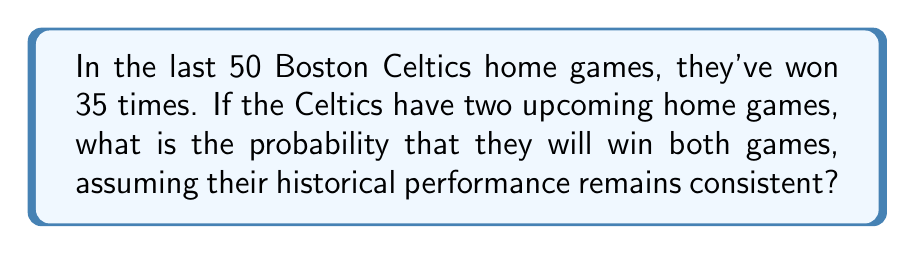Give your solution to this math problem. Let's approach this step-by-step:

1) First, we need to calculate the probability of the Celtics winning a single home game based on the given data.

   Probability of winning a home game = $\frac{\text{Number of wins}}{\text{Total games}}$
   
   $P(\text{win}) = \frac{35}{50} = 0.7$

2) Now, we need to find the probability of winning both games. Since we assume the games are independent events (the outcome of one doesn't affect the other), we can use the multiplication rule of probability.

3) For independent events, the probability of both events occurring is the product of their individual probabilities.

   $P(\text{win both}) = P(\text{win first}) \times P(\text{win second})$

4) Since the probability of winning each game is the same (0.7), we have:

   $P(\text{win both}) = 0.7 \times 0.7 = 0.7^2$

5) Calculate the final probability:

   $P(\text{win both}) = 0.7^2 = 0.49$

Therefore, the probability that the Celtics will win both upcoming home games is 0.49 or 49%.
Answer: 0.49 